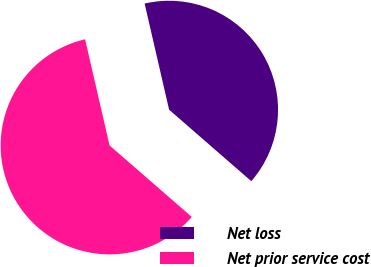<chart> <loc_0><loc_0><loc_500><loc_500><pie_chart><fcel>Net loss<fcel>Net prior service cost<nl><fcel>40.0%<fcel>60.0%<nl></chart> 